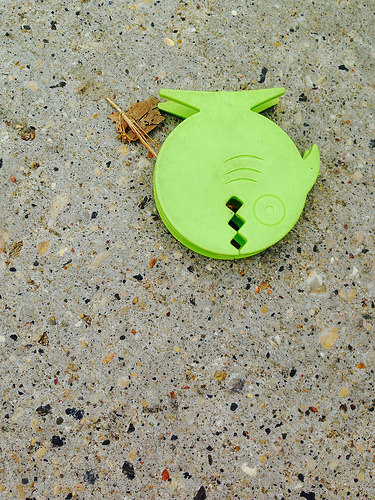<image>
Is the fish in the ground? No. The fish is not contained within the ground. These objects have a different spatial relationship. Is the fish on the ground? Yes. Looking at the image, I can see the fish is positioned on top of the ground, with the ground providing support. 